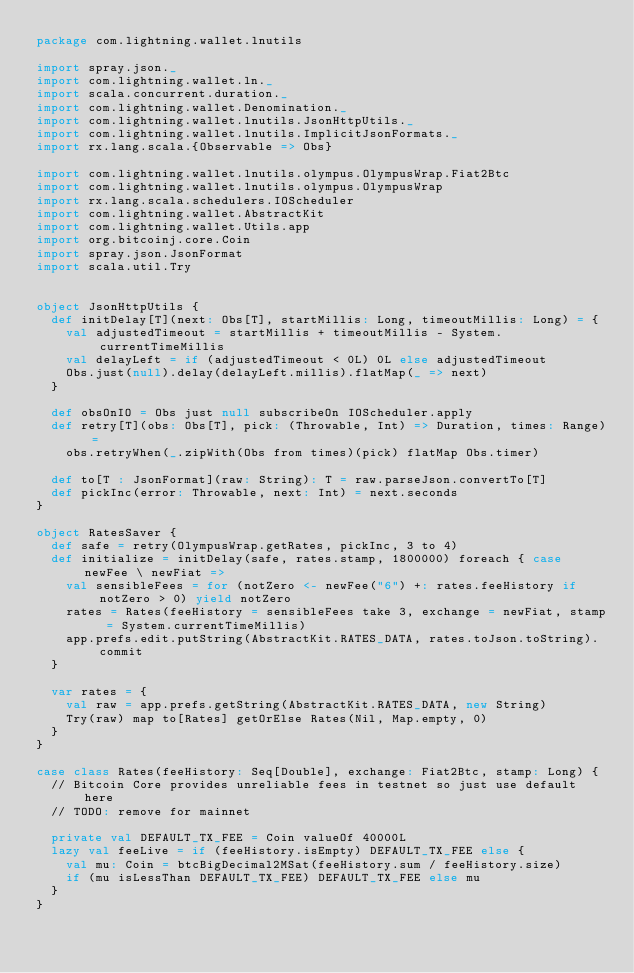Convert code to text. <code><loc_0><loc_0><loc_500><loc_500><_Scala_>package com.lightning.wallet.lnutils

import spray.json._
import com.lightning.wallet.ln._
import scala.concurrent.duration._
import com.lightning.wallet.Denomination._
import com.lightning.wallet.lnutils.JsonHttpUtils._
import com.lightning.wallet.lnutils.ImplicitJsonFormats._
import rx.lang.scala.{Observable => Obs}

import com.lightning.wallet.lnutils.olympus.OlympusWrap.Fiat2Btc
import com.lightning.wallet.lnutils.olympus.OlympusWrap
import rx.lang.scala.schedulers.IOScheduler
import com.lightning.wallet.AbstractKit
import com.lightning.wallet.Utils.app
import org.bitcoinj.core.Coin
import spray.json.JsonFormat
import scala.util.Try


object JsonHttpUtils {
  def initDelay[T](next: Obs[T], startMillis: Long, timeoutMillis: Long) = {
    val adjustedTimeout = startMillis + timeoutMillis - System.currentTimeMillis
    val delayLeft = if (adjustedTimeout < 0L) 0L else adjustedTimeout
    Obs.just(null).delay(delayLeft.millis).flatMap(_ => next)
  }

  def obsOnIO = Obs just null subscribeOn IOScheduler.apply
  def retry[T](obs: Obs[T], pick: (Throwable, Int) => Duration, times: Range) =
    obs.retryWhen(_.zipWith(Obs from times)(pick) flatMap Obs.timer)

  def to[T : JsonFormat](raw: String): T = raw.parseJson.convertTo[T]
  def pickInc(error: Throwable, next: Int) = next.seconds
}

object RatesSaver {
  def safe = retry(OlympusWrap.getRates, pickInc, 3 to 4)
  def initialize = initDelay(safe, rates.stamp, 1800000) foreach { case newFee \ newFiat =>
    val sensibleFees = for (notZero <- newFee("6") +: rates.feeHistory if notZero > 0) yield notZero
    rates = Rates(feeHistory = sensibleFees take 3, exchange = newFiat, stamp = System.currentTimeMillis)
    app.prefs.edit.putString(AbstractKit.RATES_DATA, rates.toJson.toString).commit
  }

  var rates = {
    val raw = app.prefs.getString(AbstractKit.RATES_DATA, new String)
    Try(raw) map to[Rates] getOrElse Rates(Nil, Map.empty, 0)
  }
}

case class Rates(feeHistory: Seq[Double], exchange: Fiat2Btc, stamp: Long) {
  // Bitcoin Core provides unreliable fees in testnet so just use default here
  // TODO: remove for mainnet

  private val DEFAULT_TX_FEE = Coin valueOf 40000L
  lazy val feeLive = if (feeHistory.isEmpty) DEFAULT_TX_FEE else {
    val mu: Coin = btcBigDecimal2MSat(feeHistory.sum / feeHistory.size)
    if (mu isLessThan DEFAULT_TX_FEE) DEFAULT_TX_FEE else mu
  }
}</code> 